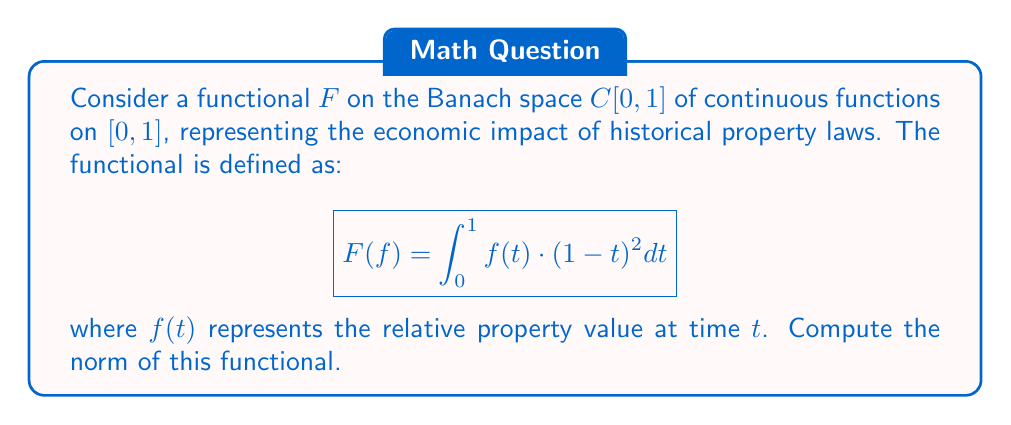What is the answer to this math problem? To find the norm of the functional $F$, we need to use the definition of the norm for a linear functional on a Banach space:

$$\|F\| = \sup_{f \in C[0,1], \|f\|_\infty \leq 1} |F(f)|$$

where $\|f\|_\infty = \max_{t \in [0,1]} |f(t)|$ is the supremum norm on $C[0,1]$.

1) First, let's consider the absolute value of $F(f)$:

   $$|F(f)| = \left|\int_0^1 f(t) \cdot (1-t)^2 dt\right| \leq \int_0^1 |f(t)| \cdot (1-t)^2 dt$$

2) Since $\|f\|_\infty \leq 1$, we know that $|f(t)| \leq 1$ for all $t \in [0,1]$. Therefore:

   $$|F(f)| \leq \int_0^1 1 \cdot (1-t)^2 dt = \int_0^1 (1-t)^2 dt$$

3) This integral can be evaluated:

   $$\int_0^1 (1-t)^2 dt = \left[-\frac{(1-t)^3}{3}\right]_0^1 = \frac{1}{3}$$

4) Thus, we have shown that $|F(f)| \leq \frac{1}{3}$ for all $f$ with $\|f\|_\infty \leq 1$.

5) To show that this bound is tight, consider the function $f(t) = 1$ for all $t \in [0,1]$. This function has $\|f\|_\infty = 1$, and:

   $$F(f) = \int_0^1 1 \cdot (1-t)^2 dt = \frac{1}{3}$$

Therefore, the supremum is achieved and $\|F\| = \frac{1}{3}$.
Answer: The norm of the functional $F$ is $\|F\| = \frac{1}{3}$. 